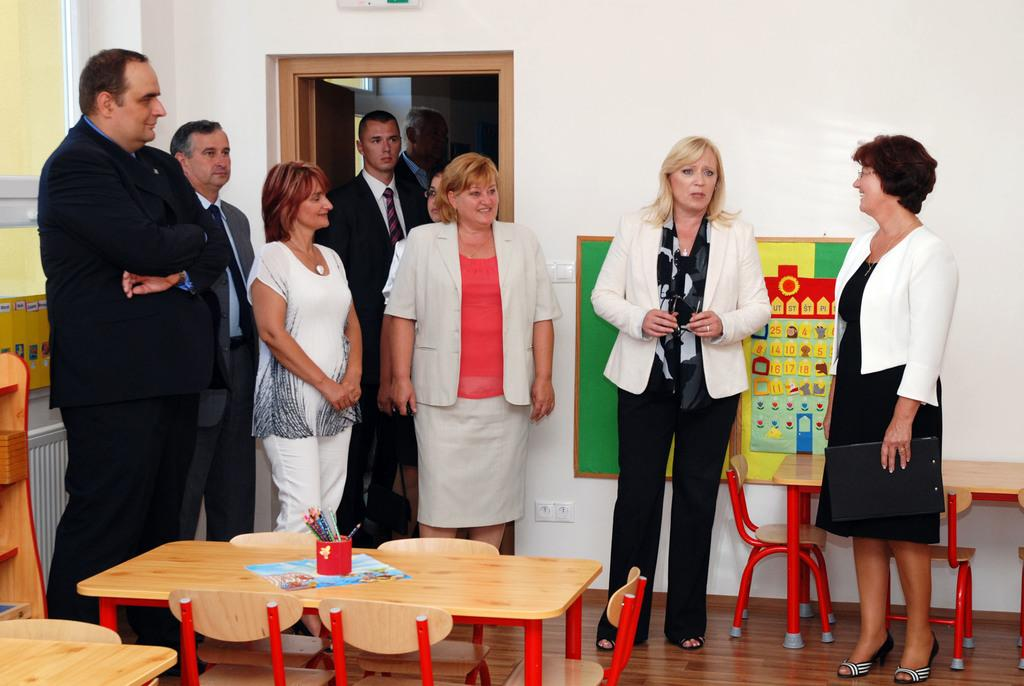What is the main subject of the image? The main subject of the image is a group of people. What objects can be seen on a table in the image? There are pens on a table in the image. What furniture is visible in the background of the image? There is a chair in the background of the image. What architectural features can be seen in the background of the image? There is a wall and a door in the background of the image. How many lizards are crawling on the wall in the image? There are no lizards present in the image; only a group of people, pens on a table, a chair, and a wall with a door are visible. 